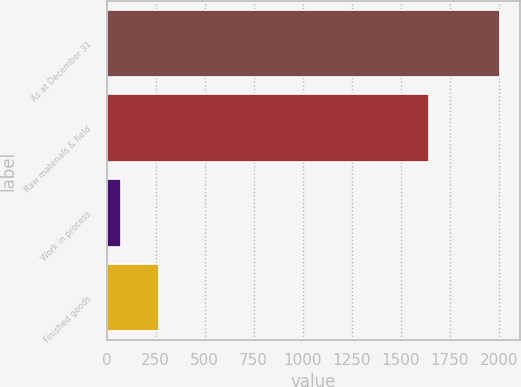Convert chart to OTSL. <chart><loc_0><loc_0><loc_500><loc_500><bar_chart><fcel>As at December 31<fcel>Raw materials & field<fcel>Work in process<fcel>Finished goods<nl><fcel>2009<fcel>1646<fcel>74<fcel>267.5<nl></chart> 